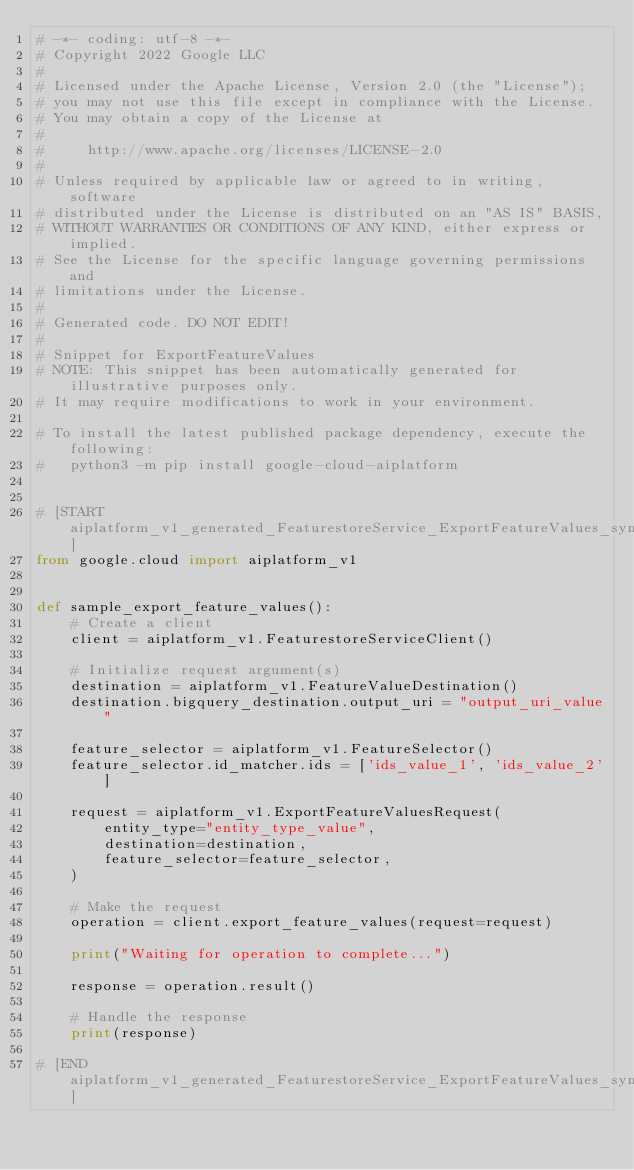Convert code to text. <code><loc_0><loc_0><loc_500><loc_500><_Python_># -*- coding: utf-8 -*-
# Copyright 2022 Google LLC
#
# Licensed under the Apache License, Version 2.0 (the "License");
# you may not use this file except in compliance with the License.
# You may obtain a copy of the License at
#
#     http://www.apache.org/licenses/LICENSE-2.0
#
# Unless required by applicable law or agreed to in writing, software
# distributed under the License is distributed on an "AS IS" BASIS,
# WITHOUT WARRANTIES OR CONDITIONS OF ANY KIND, either express or implied.
# See the License for the specific language governing permissions and
# limitations under the License.
#
# Generated code. DO NOT EDIT!
#
# Snippet for ExportFeatureValues
# NOTE: This snippet has been automatically generated for illustrative purposes only.
# It may require modifications to work in your environment.

# To install the latest published package dependency, execute the following:
#   python3 -m pip install google-cloud-aiplatform


# [START aiplatform_v1_generated_FeaturestoreService_ExportFeatureValues_sync]
from google.cloud import aiplatform_v1


def sample_export_feature_values():
    # Create a client
    client = aiplatform_v1.FeaturestoreServiceClient()

    # Initialize request argument(s)
    destination = aiplatform_v1.FeatureValueDestination()
    destination.bigquery_destination.output_uri = "output_uri_value"

    feature_selector = aiplatform_v1.FeatureSelector()
    feature_selector.id_matcher.ids = ['ids_value_1', 'ids_value_2']

    request = aiplatform_v1.ExportFeatureValuesRequest(
        entity_type="entity_type_value",
        destination=destination,
        feature_selector=feature_selector,
    )

    # Make the request
    operation = client.export_feature_values(request=request)

    print("Waiting for operation to complete...")

    response = operation.result()

    # Handle the response
    print(response)

# [END aiplatform_v1_generated_FeaturestoreService_ExportFeatureValues_sync]
</code> 